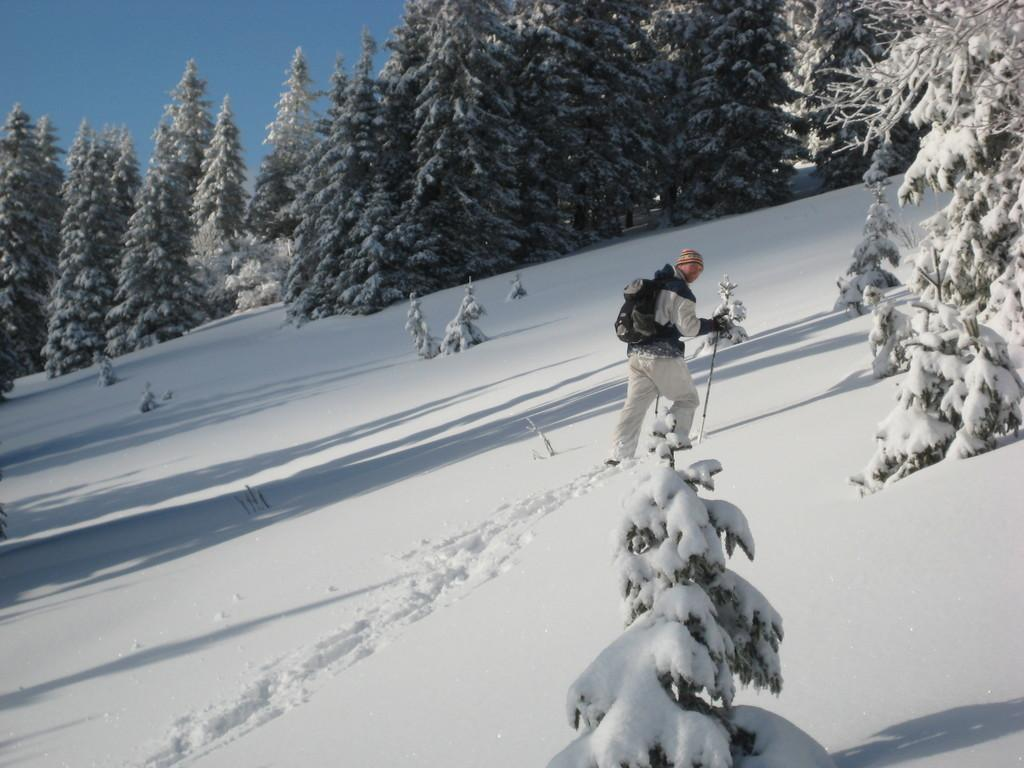Who is present in the image? There is a man in the image. What is the man doing in the image? The man is walking on the snow. What is the man holding in his hand? The man is holding a stick in his hand. What is the condition of the trees in the image? There is snow on the trees. What can be seen in the background of the image? The sky is visible in the background of the image. What type of yoke is the man using to carry the table in the image? There is no yoke or table present in the image. What month is it in the image? The month cannot be determined from the image, as there is no information about the date or time of year. 